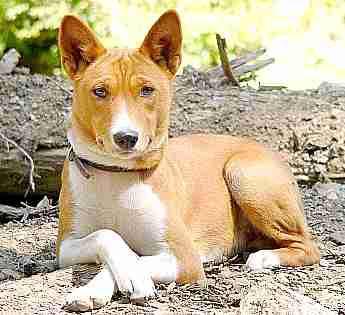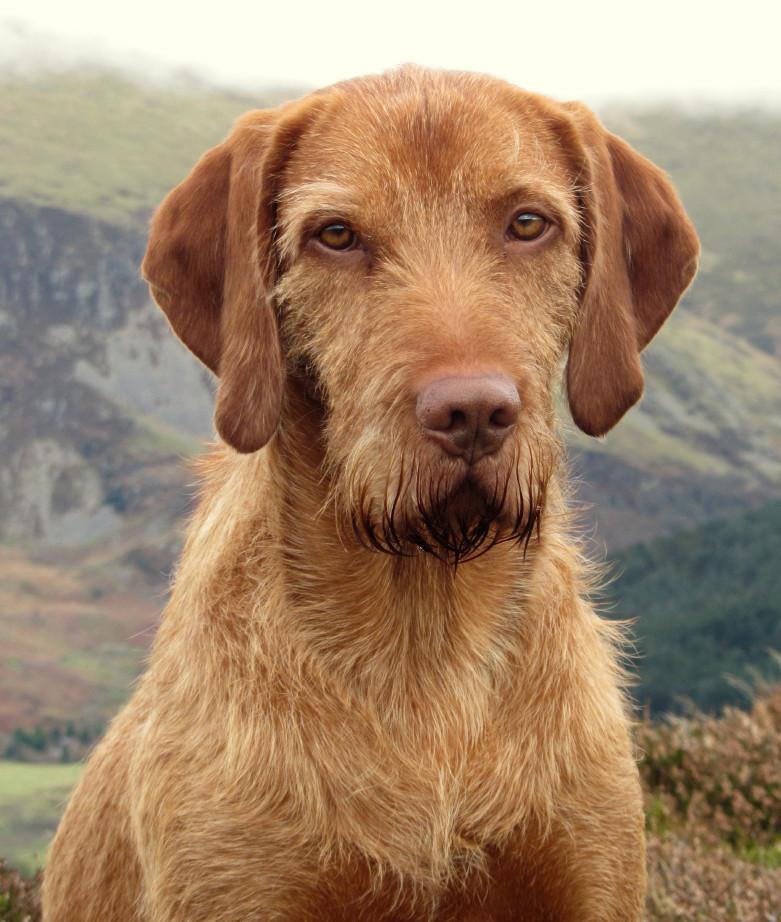The first image is the image on the left, the second image is the image on the right. Given the left and right images, does the statement "There are four dog ears visible." hold true? Answer yes or no. Yes. The first image is the image on the left, the second image is the image on the right. For the images shown, is this caption "One image shows a red-orange hound gazing somewhat forward, and the other image includes a left-facing red-orange hound with the front paw closest to the camera raised." true? Answer yes or no. No. 